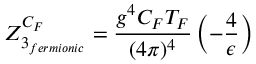<formula> <loc_0><loc_0><loc_500><loc_500>Z _ { 3 _ { f e r m i o n i c } } ^ { C _ { F } } = \frac { g ^ { 4 } C _ { F } T _ { F } } { ( 4 \pi ) ^ { 4 } } \left ( - \frac { 4 } { \epsilon } \right )</formula> 